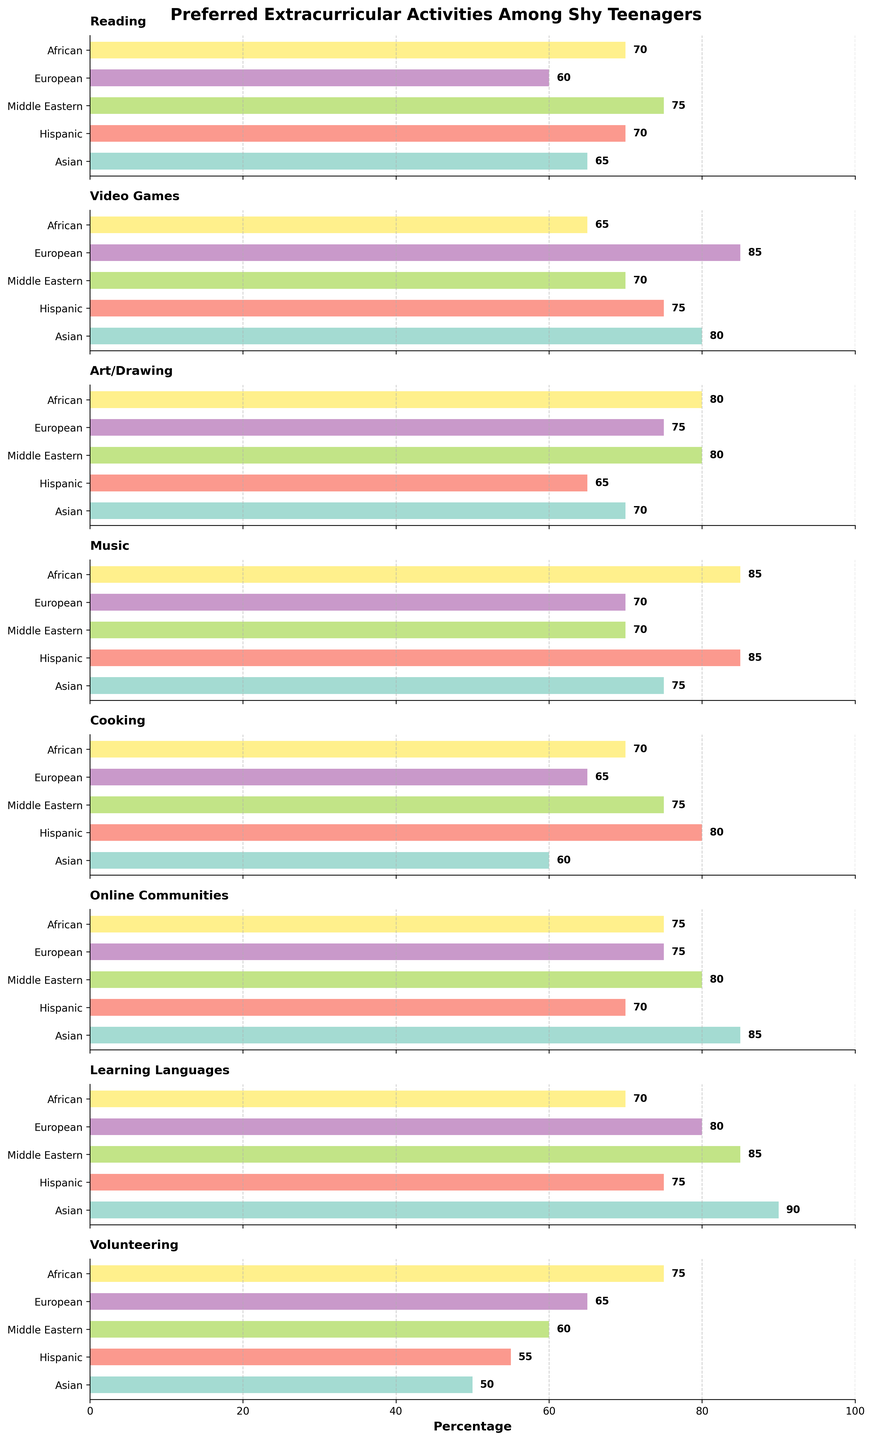What is the title of the figure? The title is generally placed at the top of the figure and summarizes the main focus of the data. In this figure, the title reads "Preferred Extracurricular Activities Among Shy Teenagers".
Answer: Preferred Extracurricular Activities Among Shy Teenagers What is the cultural background with the highest percentage in Reading activity? Look at the Reading subplot and identify which bar is the longest. The longest bar corresponds to the Middle Eastern background at 75%.
Answer: Middle Eastern Which extracurricular activity has the lowest participation among Asian teenagers? Look at the different subplots for Asian teenagers and identify the one with the smallest bar. This appears to be Volunteering with 50%.
Answer: Volunteering Compare the popularity of Video Games between European and Hispanic backgrounds. Compare the length of the bars for Video Games in the subplots for both European and Hispanic backgrounds. European teenagers have a percentage of 85%, while Hispanic teenagers have 75%.
Answer: European is higher Which activity shows the least variation in participation across all cultural backgrounds? Look for the subplot where all bars are relatively similar in length. Online Communities seems to have the most consistent bar lengths across backgrounds.
Answer: Online Communities Calculate the average percentage for Cooking among all cultural backgrounds. Sum up the percentages for Cooking (Asian: 60, Hispanic: 80, Middle Eastern: 75, European: 65, African: 70) and divide by the number of backgrounds (5). The average is (60 + 80 + 75 + 65 + 70) / 5 = 350 / 5 = 70.
Answer: 70 Is there any activity where African and Middle Eastern teenagers show the exact same participation? Compare the bars for each activity between African and Middle Eastern backgrounds. For Art/Drawing both have a participation of 80%.
Answer: Art/Drawing Which three activities have the highest percentage participation for Middle Eastern teenagers? Look at the Middle Eastern participation percentages in each subplot and identify the top three: Learning Languages (85), Reading (75), and Online Communities (80).
Answer: Learning Languages, Reading, Online Communities Find the cultural background with the highest and lowest participation in Learning Languages. Compare the lengths of the bars in the Learning Languages subplot. The highest is Asian at 90%, and the lowest is African at 70%.
Answer: Highest: Asian, Lowest: African 